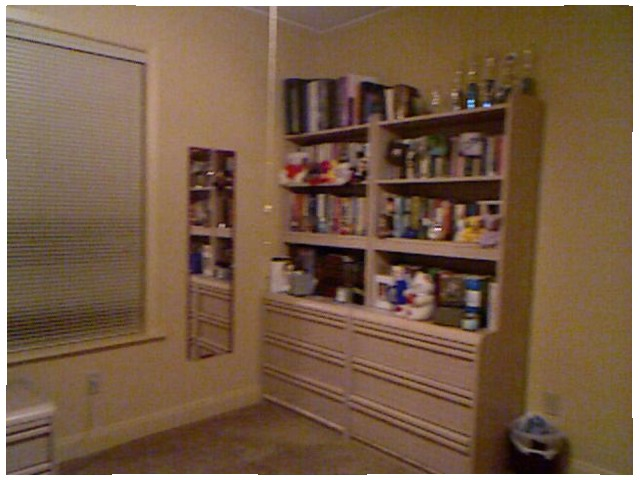<image>
Can you confirm if the mirror is under the wall? No. The mirror is not positioned under the wall. The vertical relationship between these objects is different. Where is the book in relation to the shelf? Is it on the shelf? Yes. Looking at the image, I can see the book is positioned on top of the shelf, with the shelf providing support. Where is the can in relation to the shelf? Is it to the right of the shelf? Yes. From this viewpoint, the can is positioned to the right side relative to the shelf. 